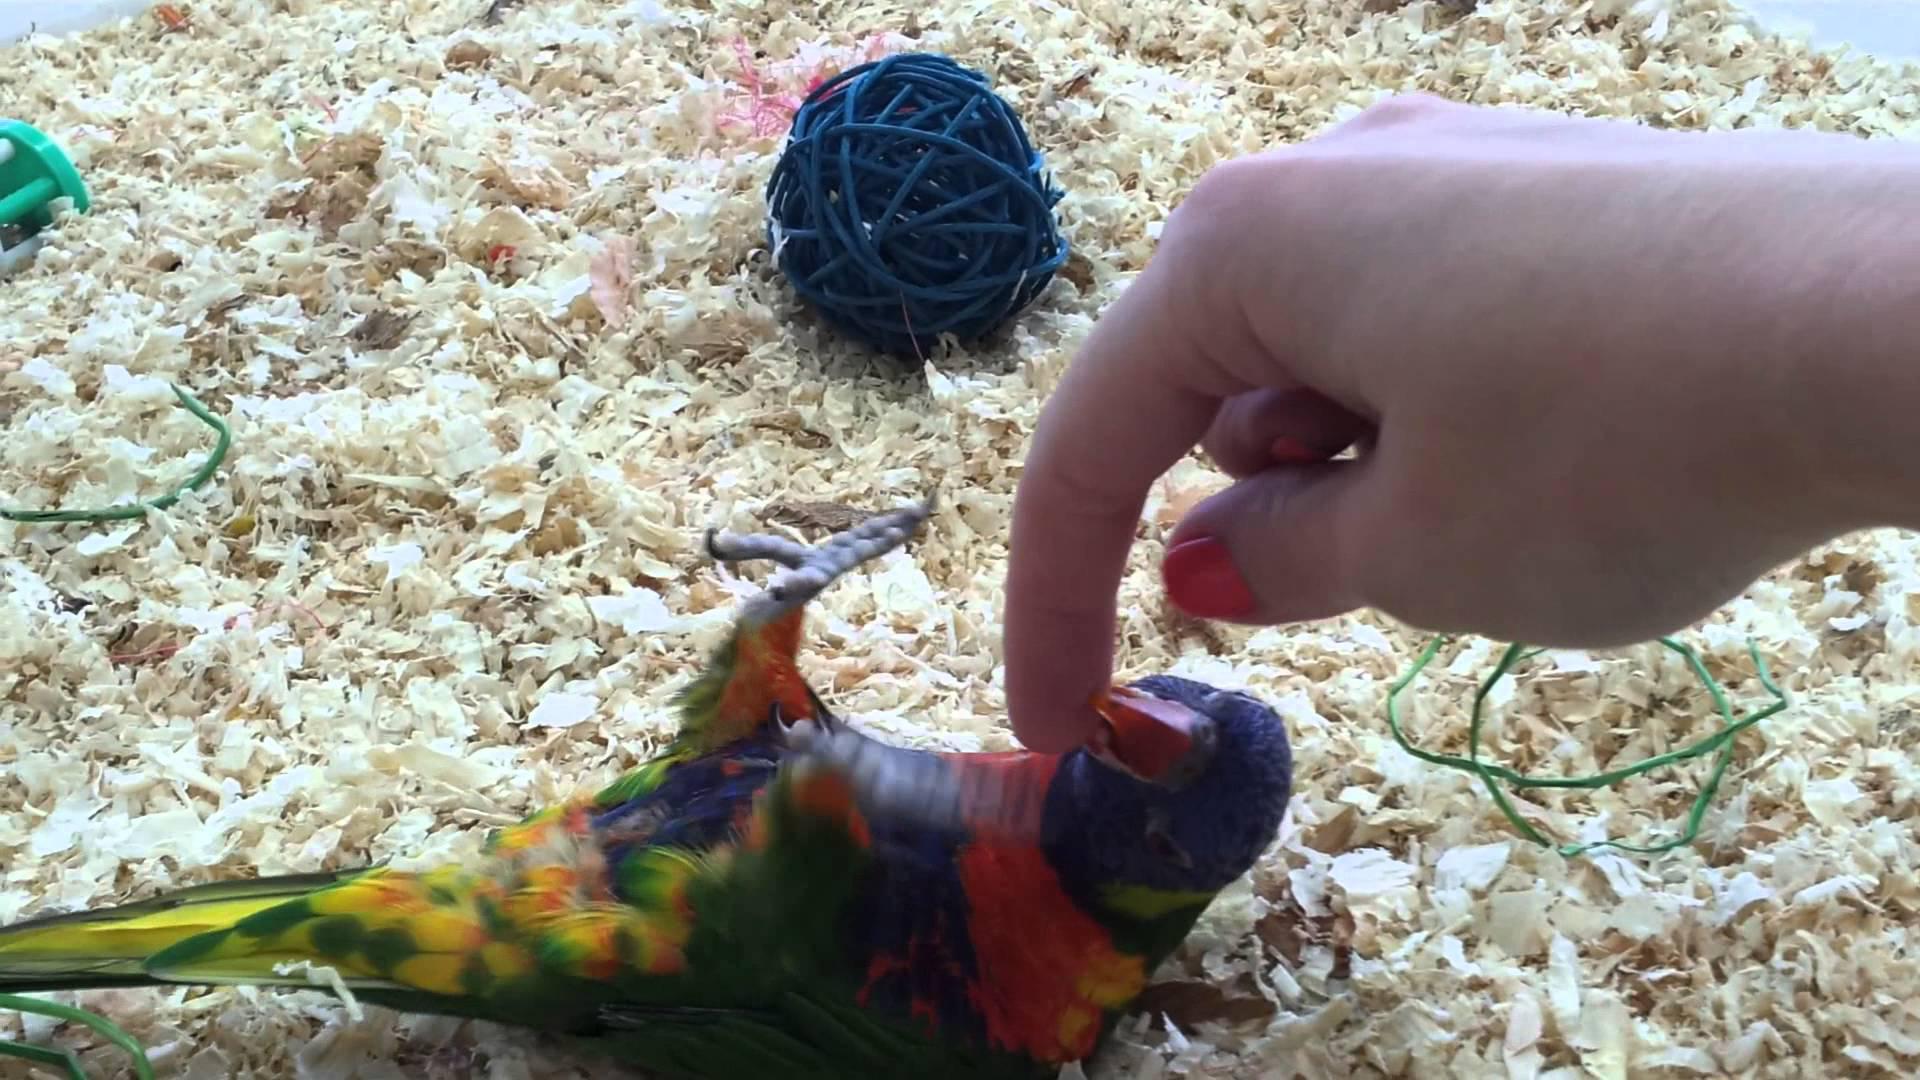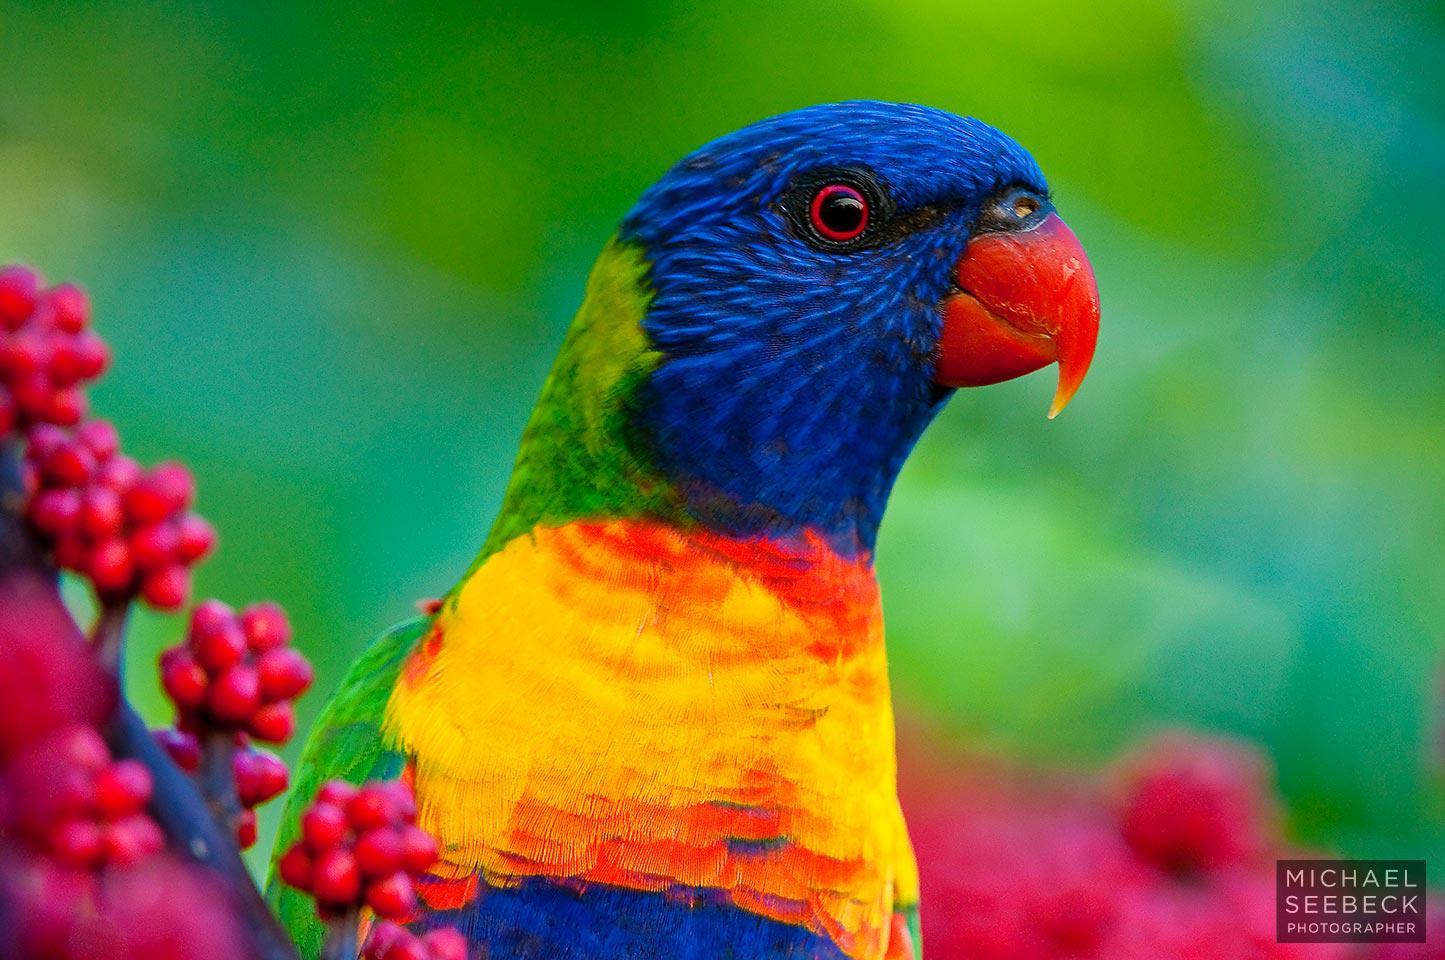The first image is the image on the left, the second image is the image on the right. Examine the images to the left and right. Is the description "Part of a human is pictured with a single bird in one of the images." accurate? Answer yes or no. Yes. The first image is the image on the left, the second image is the image on the right. Evaluate the accuracy of this statement regarding the images: "One bird is upside down.". Is it true? Answer yes or no. Yes. 